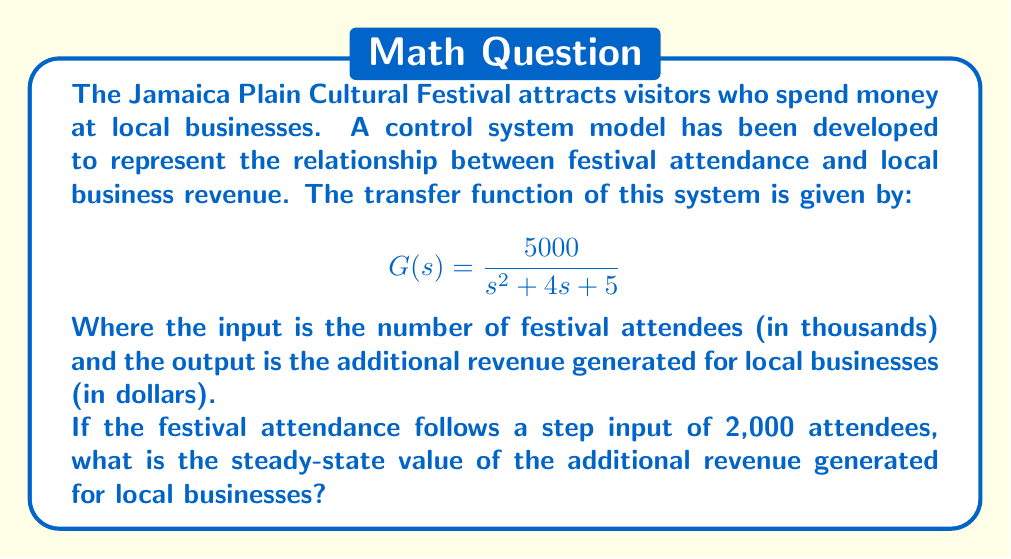Can you answer this question? To solve this problem, we need to follow these steps:

1. Identify the type of input: In this case, it's a step input of magnitude 2.

2. Recall the Final Value Theorem: For a step input, the steady-state value is given by:

   $$y_{ss} = \lim_{s \to 0} s \cdot G(s) \cdot \frac{A}{s}$$

   Where $A$ is the magnitude of the step input and $G(s)$ is the transfer function.

3. Substitute the given transfer function and input magnitude:

   $$y_{ss} = \lim_{s \to 0} s \cdot \frac{5000}{s^2 + 4s + 5} \cdot \frac{2}{s}$$

4. Simplify:

   $$y_{ss} = \lim_{s \to 0} \frac{10000}{s^2 + 4s + 5}$$

5. Apply the limit:

   $$y_{ss} = \frac{10000}{0^2 + 4(0) + 5} = \frac{10000}{5} = 2000$$

Therefore, the steady-state value of the additional revenue generated for local businesses is $2,000.
Answer: $2,000 